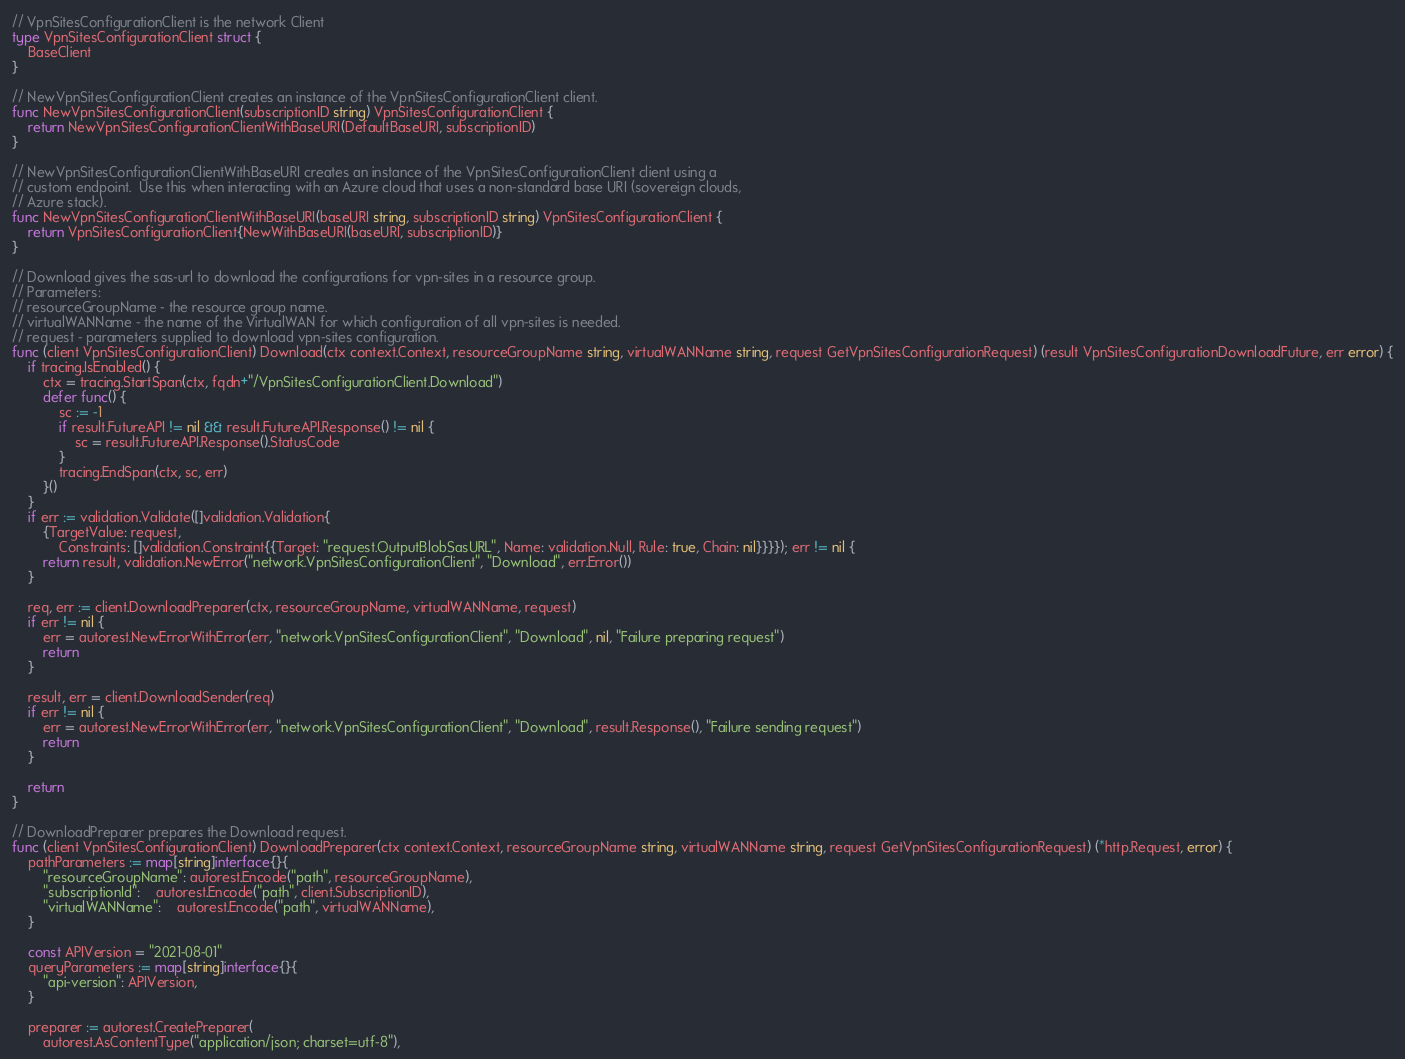<code> <loc_0><loc_0><loc_500><loc_500><_Go_>// VpnSitesConfigurationClient is the network Client
type VpnSitesConfigurationClient struct {
	BaseClient
}

// NewVpnSitesConfigurationClient creates an instance of the VpnSitesConfigurationClient client.
func NewVpnSitesConfigurationClient(subscriptionID string) VpnSitesConfigurationClient {
	return NewVpnSitesConfigurationClientWithBaseURI(DefaultBaseURI, subscriptionID)
}

// NewVpnSitesConfigurationClientWithBaseURI creates an instance of the VpnSitesConfigurationClient client using a
// custom endpoint.  Use this when interacting with an Azure cloud that uses a non-standard base URI (sovereign clouds,
// Azure stack).
func NewVpnSitesConfigurationClientWithBaseURI(baseURI string, subscriptionID string) VpnSitesConfigurationClient {
	return VpnSitesConfigurationClient{NewWithBaseURI(baseURI, subscriptionID)}
}

// Download gives the sas-url to download the configurations for vpn-sites in a resource group.
// Parameters:
// resourceGroupName - the resource group name.
// virtualWANName - the name of the VirtualWAN for which configuration of all vpn-sites is needed.
// request - parameters supplied to download vpn-sites configuration.
func (client VpnSitesConfigurationClient) Download(ctx context.Context, resourceGroupName string, virtualWANName string, request GetVpnSitesConfigurationRequest) (result VpnSitesConfigurationDownloadFuture, err error) {
	if tracing.IsEnabled() {
		ctx = tracing.StartSpan(ctx, fqdn+"/VpnSitesConfigurationClient.Download")
		defer func() {
			sc := -1
			if result.FutureAPI != nil && result.FutureAPI.Response() != nil {
				sc = result.FutureAPI.Response().StatusCode
			}
			tracing.EndSpan(ctx, sc, err)
		}()
	}
	if err := validation.Validate([]validation.Validation{
		{TargetValue: request,
			Constraints: []validation.Constraint{{Target: "request.OutputBlobSasURL", Name: validation.Null, Rule: true, Chain: nil}}}}); err != nil {
		return result, validation.NewError("network.VpnSitesConfigurationClient", "Download", err.Error())
	}

	req, err := client.DownloadPreparer(ctx, resourceGroupName, virtualWANName, request)
	if err != nil {
		err = autorest.NewErrorWithError(err, "network.VpnSitesConfigurationClient", "Download", nil, "Failure preparing request")
		return
	}

	result, err = client.DownloadSender(req)
	if err != nil {
		err = autorest.NewErrorWithError(err, "network.VpnSitesConfigurationClient", "Download", result.Response(), "Failure sending request")
		return
	}

	return
}

// DownloadPreparer prepares the Download request.
func (client VpnSitesConfigurationClient) DownloadPreparer(ctx context.Context, resourceGroupName string, virtualWANName string, request GetVpnSitesConfigurationRequest) (*http.Request, error) {
	pathParameters := map[string]interface{}{
		"resourceGroupName": autorest.Encode("path", resourceGroupName),
		"subscriptionId":    autorest.Encode("path", client.SubscriptionID),
		"virtualWANName":    autorest.Encode("path", virtualWANName),
	}

	const APIVersion = "2021-08-01"
	queryParameters := map[string]interface{}{
		"api-version": APIVersion,
	}

	preparer := autorest.CreatePreparer(
		autorest.AsContentType("application/json; charset=utf-8"),</code> 